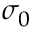Convert formula to latex. <formula><loc_0><loc_0><loc_500><loc_500>\sigma _ { 0 }</formula> 